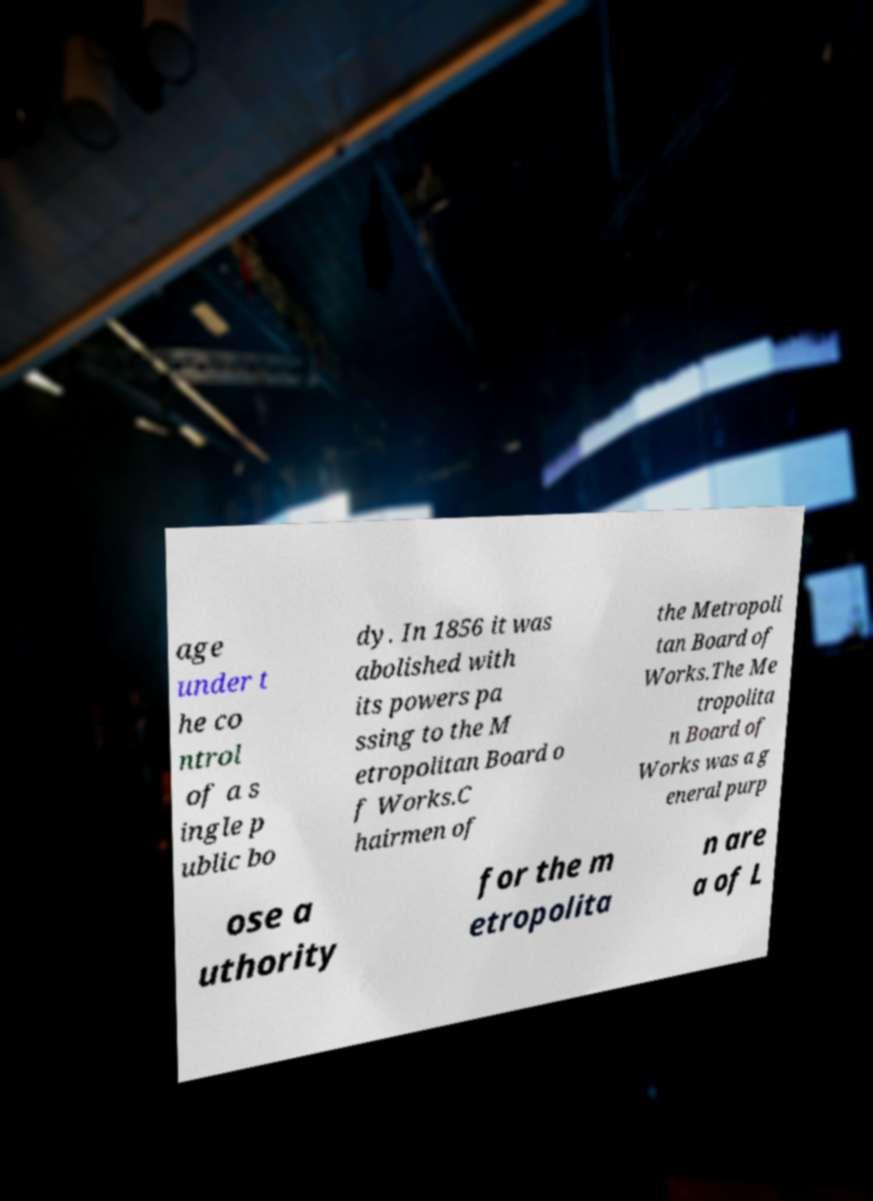What messages or text are displayed in this image? I need them in a readable, typed format. age under t he co ntrol of a s ingle p ublic bo dy. In 1856 it was abolished with its powers pa ssing to the M etropolitan Board o f Works.C hairmen of the Metropoli tan Board of Works.The Me tropolita n Board of Works was a g eneral purp ose a uthority for the m etropolita n are a of L 